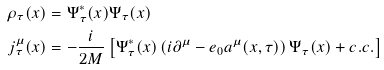Convert formula to latex. <formula><loc_0><loc_0><loc_500><loc_500>\rho _ { \tau } ( x ) & = \Psi ^ { * } _ { \tau } ( x ) \Psi _ { \tau } ( x ) \\ j ^ { \mu } _ { \tau } ( x ) & = - \frac { i } { 2 M } \left [ \Psi ^ { * } _ { \tau } ( x ) \left ( i \partial ^ { \mu } - e _ { 0 } a ^ { \mu } ( x , \tau ) \right ) \Psi _ { \tau } ( x ) + c . c . \right ]</formula> 